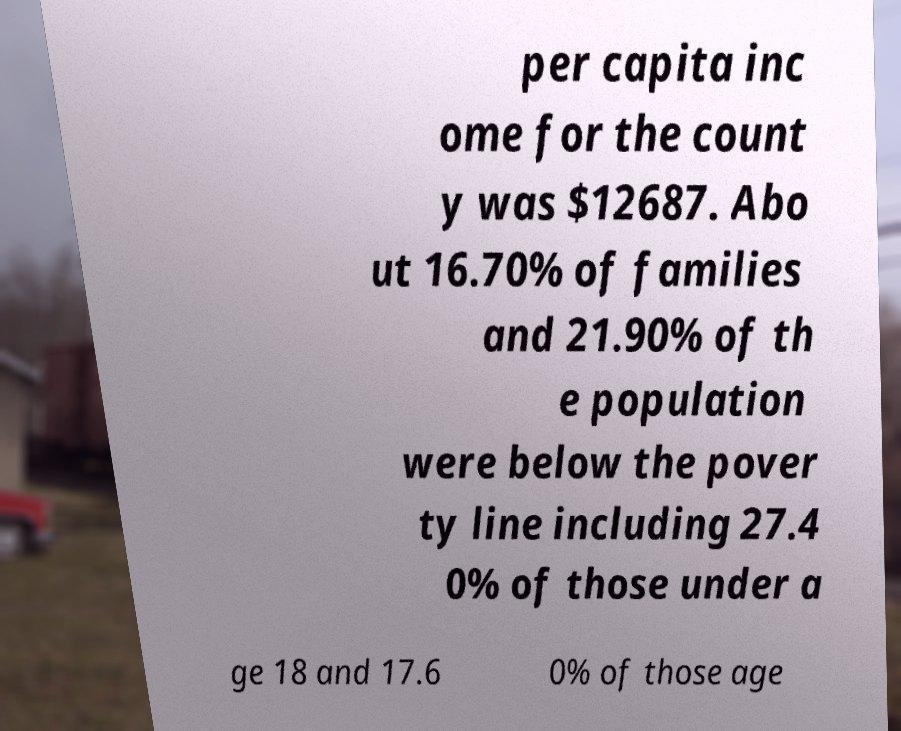Please read and relay the text visible in this image. What does it say? per capita inc ome for the count y was $12687. Abo ut 16.70% of families and 21.90% of th e population were below the pover ty line including 27.4 0% of those under a ge 18 and 17.6 0% of those age 